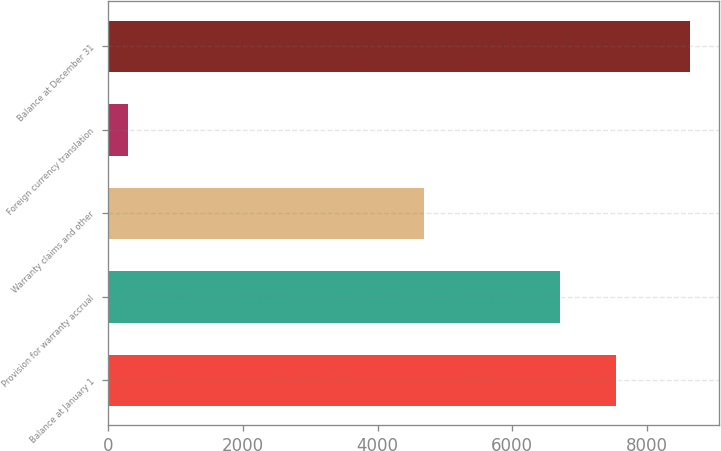Convert chart to OTSL. <chart><loc_0><loc_0><loc_500><loc_500><bar_chart><fcel>Balance at January 1<fcel>Provision for warranty accrual<fcel>Warranty claims and other<fcel>Foreign currency translation<fcel>Balance at December 31<nl><fcel>7534.6<fcel>6701<fcel>4692<fcel>295<fcel>8631<nl></chart> 